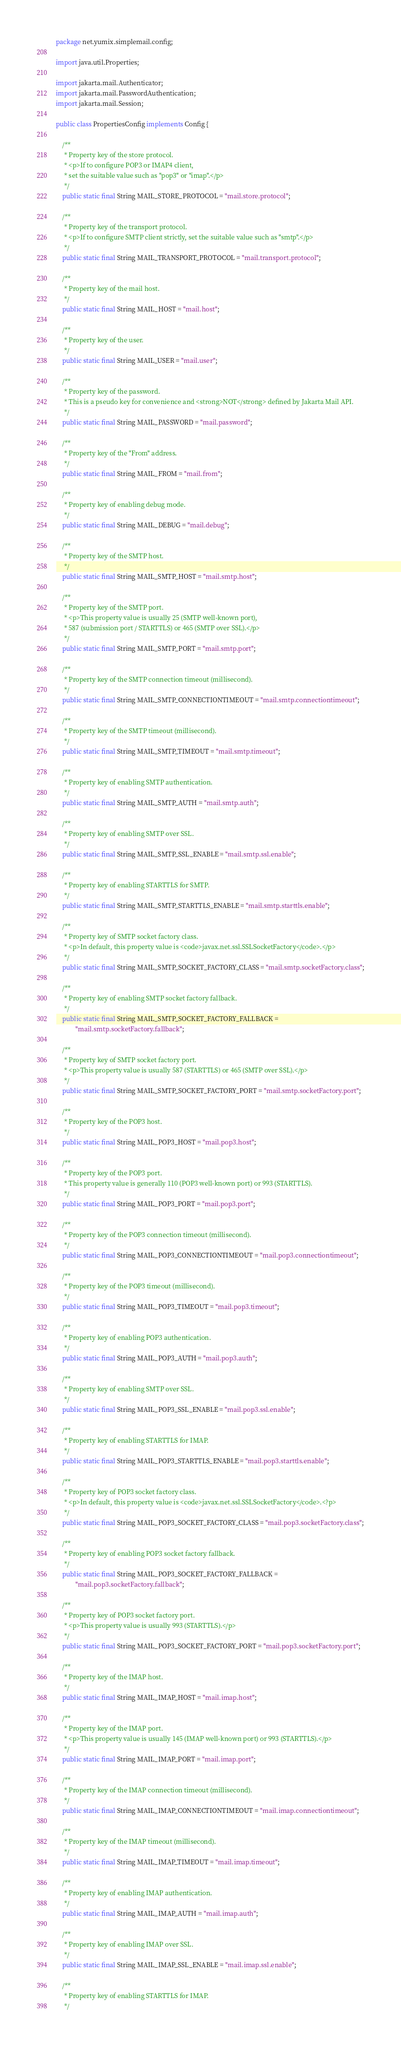<code> <loc_0><loc_0><loc_500><loc_500><_Java_>package net.yumix.simplemail.config;

import java.util.Properties;

import jakarta.mail.Authenticator;
import jakarta.mail.PasswordAuthentication;
import jakarta.mail.Session;

public class PropertiesConfig implements Config {
    
    /**
     * Property key of the store protocol.
     * <p>If to configure POP3 or IMAP4 client, 
     * set the suitable value such as "pop3" or "imap".</p>
     */
    public static final String MAIL_STORE_PROTOCOL = "mail.store.protocol";
    
    /**
     * Property key of the transport protocol.
     * <p>If to configure SMTP client strictly, set the suitable value such as "smtp".</p>
     */
    public static final String MAIL_TRANSPORT_PROTOCOL = "mail.transport.protocol";
    
    /**
     * Property key of the mail host.
     */
    public static final String MAIL_HOST = "mail.host";
    
    /**
     * Property key of the user.
     */
    public static final String MAIL_USER = "mail.user";
    
    /**
     * Property key of the password. 
     * This is a pseudo key for convenience and <strong>NOT</strong> defined by Jakarta Mail API.
     */
    public static final String MAIL_PASSWORD = "mail.password";
    
    /**
     * Property key of the "From" address.
     */
    public static final String MAIL_FROM = "mail.from";
    
    /**
     * Property key of enabling debug mode.
     */
    public static final String MAIL_DEBUG = "mail.debug";
    
    /**
     * Property key of the SMTP host.
     */
    public static final String MAIL_SMTP_HOST = "mail.smtp.host";
    
    /**
     * Property key of the SMTP port.
     * <p>This property value is usually 25 (SMTP well-known port), 
     * 587 (submission port / STARTTLS) or 465 (SMTP over SSL).</p>
     */
    public static final String MAIL_SMTP_PORT = "mail.smtp.port";
    
    /**
     * Property key of the SMTP connection timeout (millisecond).
     */
    public static final String MAIL_SMTP_CONNECTIONTIMEOUT = "mail.smtp.connectiontimeout";
    
    /**
     * Property key of the SMTP timeout (millisecond).
     */
    public static final String MAIL_SMTP_TIMEOUT = "mail.smtp.timeout";
    
    /**
     * Property key of enabling SMTP authentication.
     */
    public static final String MAIL_SMTP_AUTH = "mail.smtp.auth";
    
    /**
     * Property key of enabling SMTP over SSL.
     */
    public static final String MAIL_SMTP_SSL_ENABLE = "mail.smtp.ssl.enable";
    
    /**
     * Property key of enabling STARTTLS for SMTP.
     */
    public static final String MAIL_SMTP_STARTTLS_ENABLE = "mail.smtp.starttls.enable";
    
    /**
     * Property key of SMTP socket factory class.
     * <p>In default, this property value is <code>javax.net.ssl.SSLSocketFactory</code>.</p>
     */
    public static final String MAIL_SMTP_SOCKET_FACTORY_CLASS = "mail.smtp.socketFactory.class";
    
    /**
     * Property key of enabling SMTP socket factory fallback.
     */
    public static final String MAIL_SMTP_SOCKET_FACTORY_FALLBACK = 
            "mail.smtp.socketFactory.fallback";
    
    /**
     * Property key of SMTP socket factory port.
     * <p>This property value is usually 587 (STARTTLS) or 465 (SMTP over SSL).</p>
     */
    public static final String MAIL_SMTP_SOCKET_FACTORY_PORT = "mail.smtp.socketFactory.port";
    
    /**
     * Property key of the POP3 host.
     */
    public static final String MAIL_POP3_HOST = "mail.pop3.host";
    
    /**
     * Property key of the POP3 port.
     * This property value is generally 110 (POP3 well-known port) or 993 (STARTTLS).
     */
    public static final String MAIL_POP3_PORT = "mail.pop3.port";
    
    /**
     * Property key of the POP3 connection timeout (millisecond).
     */
    public static final String MAIL_POP3_CONNECTIONTIMEOUT = "mail.pop3.connectiontimeout";
    
    /**
     * Property key of the POP3 timeout (millisecond).
     */
    public static final String MAIL_POP3_TIMEOUT = "mail.pop3.timeout";
    
    /**
     * Property key of enabling POP3 authentication.
     */
    public static final String MAIL_POP3_AUTH = "mail.pop3.auth";
    
    /**
     * Property key of enabling SMTP over SSL.
     */
    public static final String MAIL_POP3_SSL_ENABLE = "mail.pop3.ssl.enable";
    
    /**
     * Property key of enabling STARTTLS for IMAP.
     */
    public static final String MAIL_POP3_STARTTLS_ENABLE = "mail.pop3.starttls.enable";
    
    /**
     * Property key of POP3 socket factory class.
     * <p>In default, this property value is <code>javax.net.ssl.SSLSocketFactory</code>.<?p>
     */
    public static final String MAIL_POP3_SOCKET_FACTORY_CLASS = "mail.pop3.socketFactory.class";
    
    /**
     * Property key of enabling POP3 socket factory fallback.
     */
    public static final String MAIL_POP3_SOCKET_FACTORY_FALLBACK = 
            "mail.pop3.socketFactory.fallback";
    
    /**
     * Property key of POP3 socket factory port.
     * <p>This property value is usually 993 (STARTTLS).</p>
     */
    public static final String MAIL_POP3_SOCKET_FACTORY_PORT = "mail.pop3.socketFactory.port";
    
    /**
     * Property key of the IMAP host.
     */
    public static final String MAIL_IMAP_HOST = "mail.imap.host";
    
    /**
     * Property key of the IMAP port.
     * <p>This property value is usually 145 (IMAP well-known port) or 993 (STARTTLS).</p>
     */
    public static final String MAIL_IMAP_PORT = "mail.imap.port";
    
    /**
     * Property key of the IMAP connection timeout (millisecond).
     */
    public static final String MAIL_IMAP_CONNECTIONTIMEOUT = "mail.imap.connectiontimeout";
    
    /**
     * Property key of the IMAP timeout (millisecond).
     */
    public static final String MAIL_IMAP_TIMEOUT = "mail.imap.timeout";
    
    /**
     * Property key of enabling IMAP authentication.
     */
    public static final String MAIL_IMAP_AUTH = "mail.imap.auth";
    
    /**
     * Property key of enabling IMAP over SSL.
     */
    public static final String MAIL_IMAP_SSL_ENABLE = "mail.imap.ssl.enable";
    
    /**
     * Property key of enabling STARTTLS for IMAP.
     */</code> 